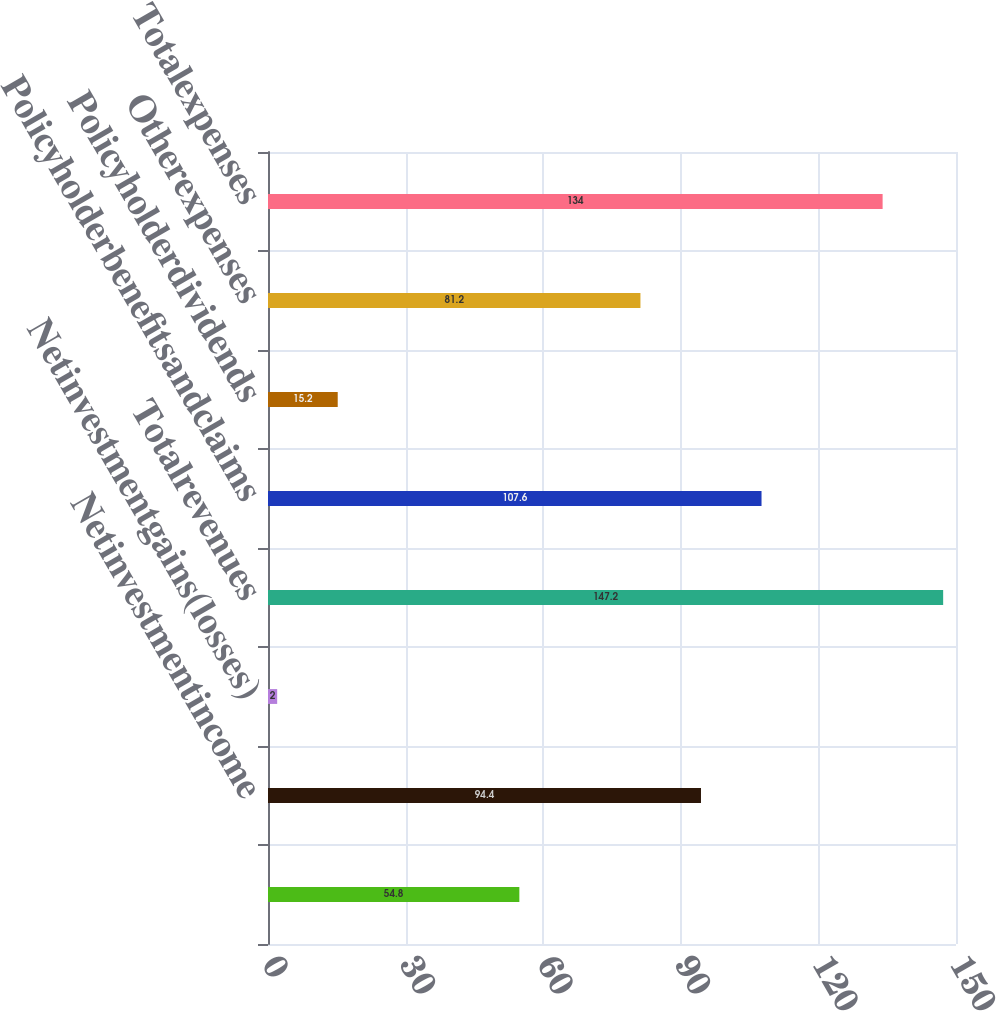Convert chart. <chart><loc_0><loc_0><loc_500><loc_500><bar_chart><ecel><fcel>Netinvestmentincome<fcel>Netinvestmentgains(losses)<fcel>Totalrevenues<fcel>Policyholderbenefitsandclaims<fcel>Policyholderdividends<fcel>Otherexpenses<fcel>Totalexpenses<nl><fcel>54.8<fcel>94.4<fcel>2<fcel>147.2<fcel>107.6<fcel>15.2<fcel>81.2<fcel>134<nl></chart> 